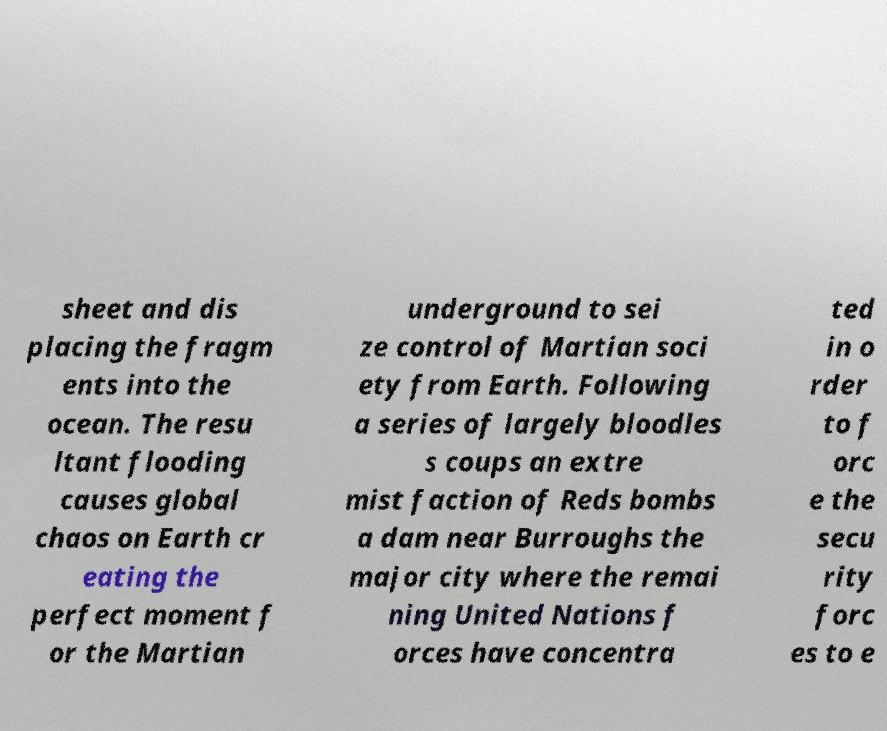Could you assist in decoding the text presented in this image and type it out clearly? sheet and dis placing the fragm ents into the ocean. The resu ltant flooding causes global chaos on Earth cr eating the perfect moment f or the Martian underground to sei ze control of Martian soci ety from Earth. Following a series of largely bloodles s coups an extre mist faction of Reds bombs a dam near Burroughs the major city where the remai ning United Nations f orces have concentra ted in o rder to f orc e the secu rity forc es to e 